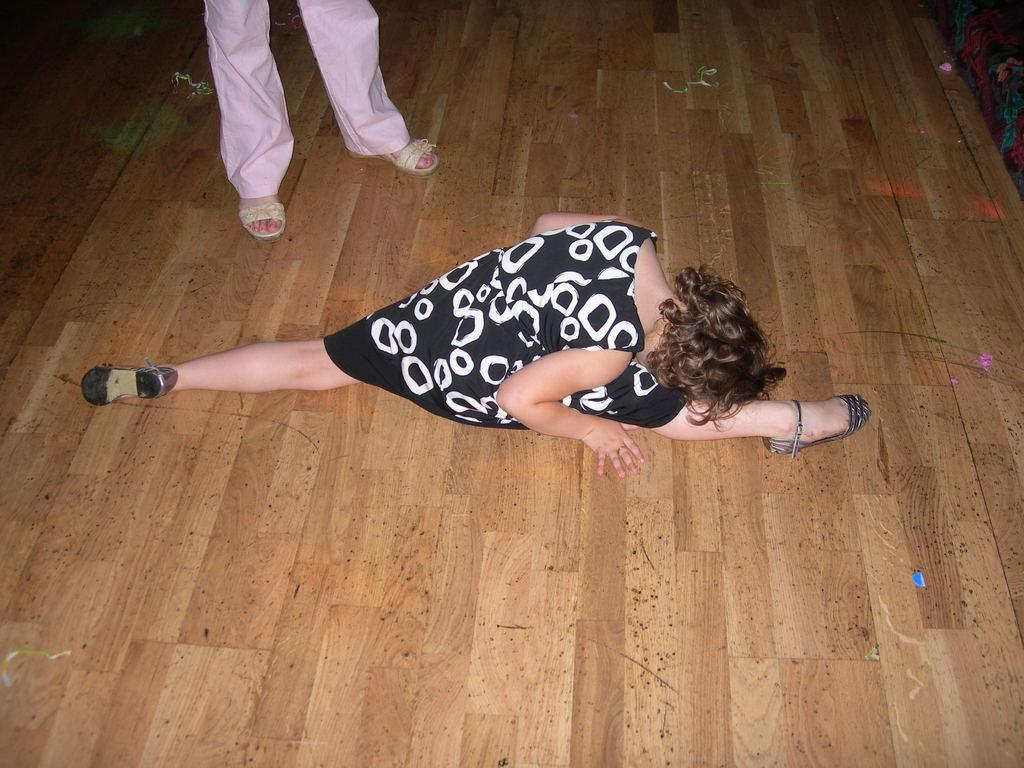What is the main subject of the image? There is a woman in the center of the image who is dancing. What type of surface is the woman dancing on? There is a wooden floor at the bottom of the image. Can you describe the background of the image? There is another person standing in the background of the image. How many chickens are present in the image? There are no chickens present in the image. What type of finger is the woman using to dance in the image? The image does not show the woman using any specific finger to dance; she is using her entire body to dance. 